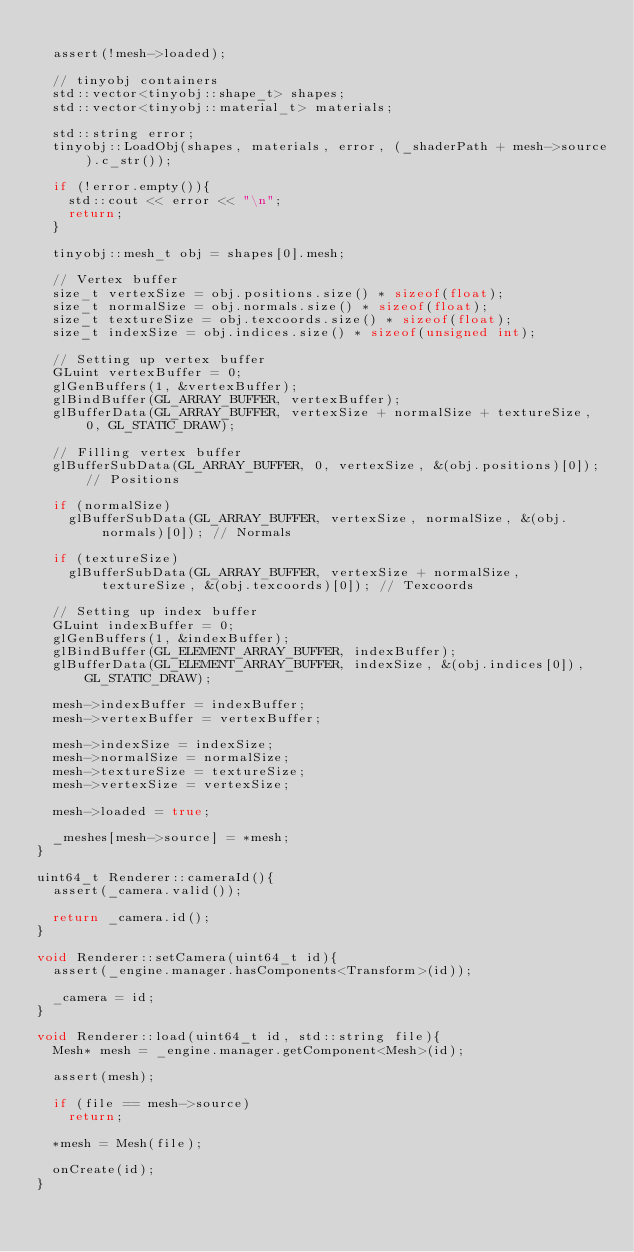<code> <loc_0><loc_0><loc_500><loc_500><_C++_>
	assert(!mesh->loaded);

	// tinyobj containers
	std::vector<tinyobj::shape_t> shapes;
	std::vector<tinyobj::material_t> materials;

	std::string error;
	tinyobj::LoadObj(shapes, materials, error, (_shaderPath + mesh->source).c_str());

	if (!error.empty()){
		std::cout << error << "\n";
		return;
	}

	tinyobj::mesh_t obj = shapes[0].mesh;

	// Vertex buffer
	size_t vertexSize = obj.positions.size() * sizeof(float);
	size_t normalSize = obj.normals.size() * sizeof(float);
	size_t textureSize = obj.texcoords.size() * sizeof(float);
	size_t indexSize = obj.indices.size() * sizeof(unsigned int);

	// Setting up vertex buffer
	GLuint vertexBuffer = 0;
	glGenBuffers(1, &vertexBuffer);
	glBindBuffer(GL_ARRAY_BUFFER, vertexBuffer);
	glBufferData(GL_ARRAY_BUFFER, vertexSize + normalSize + textureSize, 0, GL_STATIC_DRAW);

	// Filling vertex buffer
	glBufferSubData(GL_ARRAY_BUFFER, 0, vertexSize, &(obj.positions)[0]); // Positions

	if (normalSize)
		glBufferSubData(GL_ARRAY_BUFFER, vertexSize, normalSize, &(obj.normals)[0]); // Normals

	if (textureSize)
		glBufferSubData(GL_ARRAY_BUFFER, vertexSize + normalSize, textureSize, &(obj.texcoords)[0]); // Texcoords
	
	// Setting up index buffer
	GLuint indexBuffer = 0;
	glGenBuffers(1, &indexBuffer);
	glBindBuffer(GL_ELEMENT_ARRAY_BUFFER, indexBuffer);
	glBufferData(GL_ELEMENT_ARRAY_BUFFER, indexSize, &(obj.indices[0]), GL_STATIC_DRAW);

	mesh->indexBuffer = indexBuffer;
	mesh->vertexBuffer = vertexBuffer;

	mesh->indexSize = indexSize;
	mesh->normalSize = normalSize;
	mesh->textureSize = textureSize;
	mesh->vertexSize = vertexSize;

	mesh->loaded = true;

	_meshes[mesh->source] = *mesh;
}

uint64_t Renderer::cameraId(){
	assert(_camera.valid());

	return _camera.id();
}

void Renderer::setCamera(uint64_t id){
	assert(_engine.manager.hasComponents<Transform>(id));

	_camera = id;
}

void Renderer::load(uint64_t id, std::string file){
	Mesh* mesh = _engine.manager.getComponent<Mesh>(id);

	assert(mesh);

	if (file == mesh->source)
		return;

	*mesh = Mesh(file);

	onCreate(id);
}
</code> 